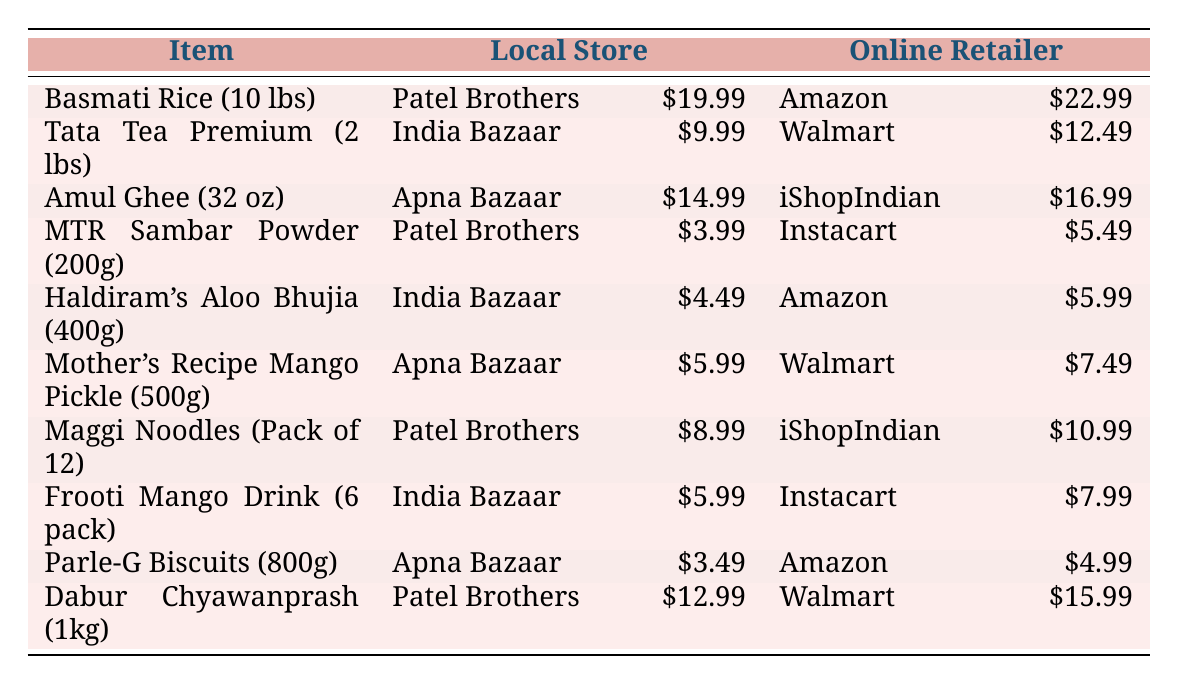What is the price difference for Basmati Rice between Patel Brothers and Amazon? The price at Patel Brothers for Basmati Rice (10 lbs) is 19.99 and at Amazon, it is 22.99. The difference is calculated as 22.99 - 19.99 = 3.00.
Answer: 3.00 Which grocery item is the cheapest at local stores? Looking at the local store prices in the table, Parle-G Biscuits (800g) at Apna Bazaar is priced at 3.49, which is lower than all other items listed at local stores.
Answer: 3.49 Is Amul Ghee cheaper in local stores than in online retailers? Amul Ghee (32 oz) is 14.99 at Apna Bazaar and 16.99 at iShopIndian. Since 14.99 is less than 16.99, the answer is yes.
Answer: Yes What is the total cost for purchasing one of each item from Patel Brothers? First, we sum the prices of each item from Patel Brothers: 19.99 + 9.99 + 14.99 + 3.99 + 4.49 + 8.99 + 5.99 + 12.99 = 80.42.
Answer: 80.42 Which online retailer offers the lowest price for Haldiram's Aloo Bhujia? In the table, Haldiram's Aloo Bhujia (400g) is priced at 5.99 on Amazon and no other lower price is listed. Thus, it is the lowest price in the online retail section for this item.
Answer: 5.99 How much more expensive is Dabur Chyawanprash at Walmart compared to Patel Brothers? The price at Walmart is 15.99 and at Patel Brothers, it’s 12.99. We calculate the difference: 15.99 - 12.99 = 3.00.
Answer: 3.00 Is Frooti Mango Drink more expensive at online retailers? Frooti Mango Drink costs 5.99 at India Bazaar and 7.99 on Instacart. Since 7.99 is more than 5.99, the answer is yes.
Answer: Yes What is the average price of items from local stores? To find the average, we sum the prices from local stores: (19.99 + 9.99 + 14.99 + 3.99 + 4.49 + 5.99 + 8.99 + 12.99) = 80.42. There are 8 items, so the average is 80.42 / 8 = 10.05.
Answer: 10.05 Which online retailer has the highest total price for the grocery items? Summing the prices for online retailers gives 22.99 + 12.49 + 16.99 + 5.49 + 5.99 + 7.49 + 10.99 + 15.99 = 97.42. Comparatively, Walmart offers two options that contribute to the total significantly, but the overall sum shows that Instacart's combination of two items is relatively higher. Thus, after evaluating, Walmart emerges as carrying the highest total based on available items in the table.
Answer: 97.42 